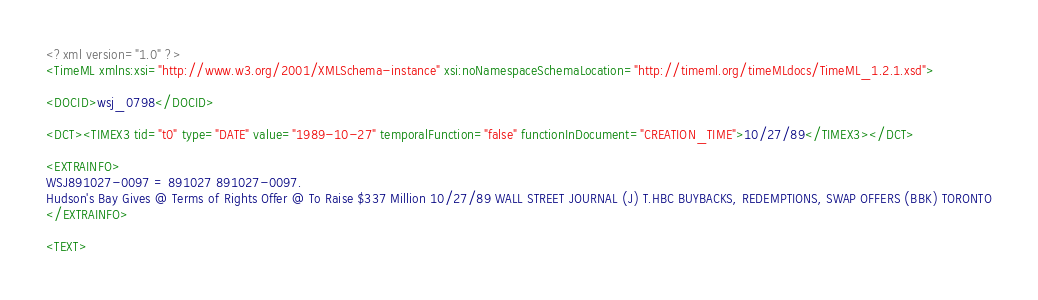Convert code to text. <code><loc_0><loc_0><loc_500><loc_500><_XML_><?xml version="1.0" ?>
<TimeML xmlns:xsi="http://www.w3.org/2001/XMLSchema-instance" xsi:noNamespaceSchemaLocation="http://timeml.org/timeMLdocs/TimeML_1.2.1.xsd">

<DOCID>wsj_0798</DOCID>

<DCT><TIMEX3 tid="t0" type="DATE" value="1989-10-27" temporalFunction="false" functionInDocument="CREATION_TIME">10/27/89</TIMEX3></DCT>

<EXTRAINFO>
WSJ891027-0097 = 891027 891027-0097.
Hudson's Bay Gives @ Terms of Rights Offer @ To Raise $337 Million 10/27/89 WALL STREET JOURNAL (J) T.HBC BUYBACKS, REDEMPTIONS, SWAP OFFERS (BBK) TORONTO
</EXTRAINFO>

<TEXT></code> 